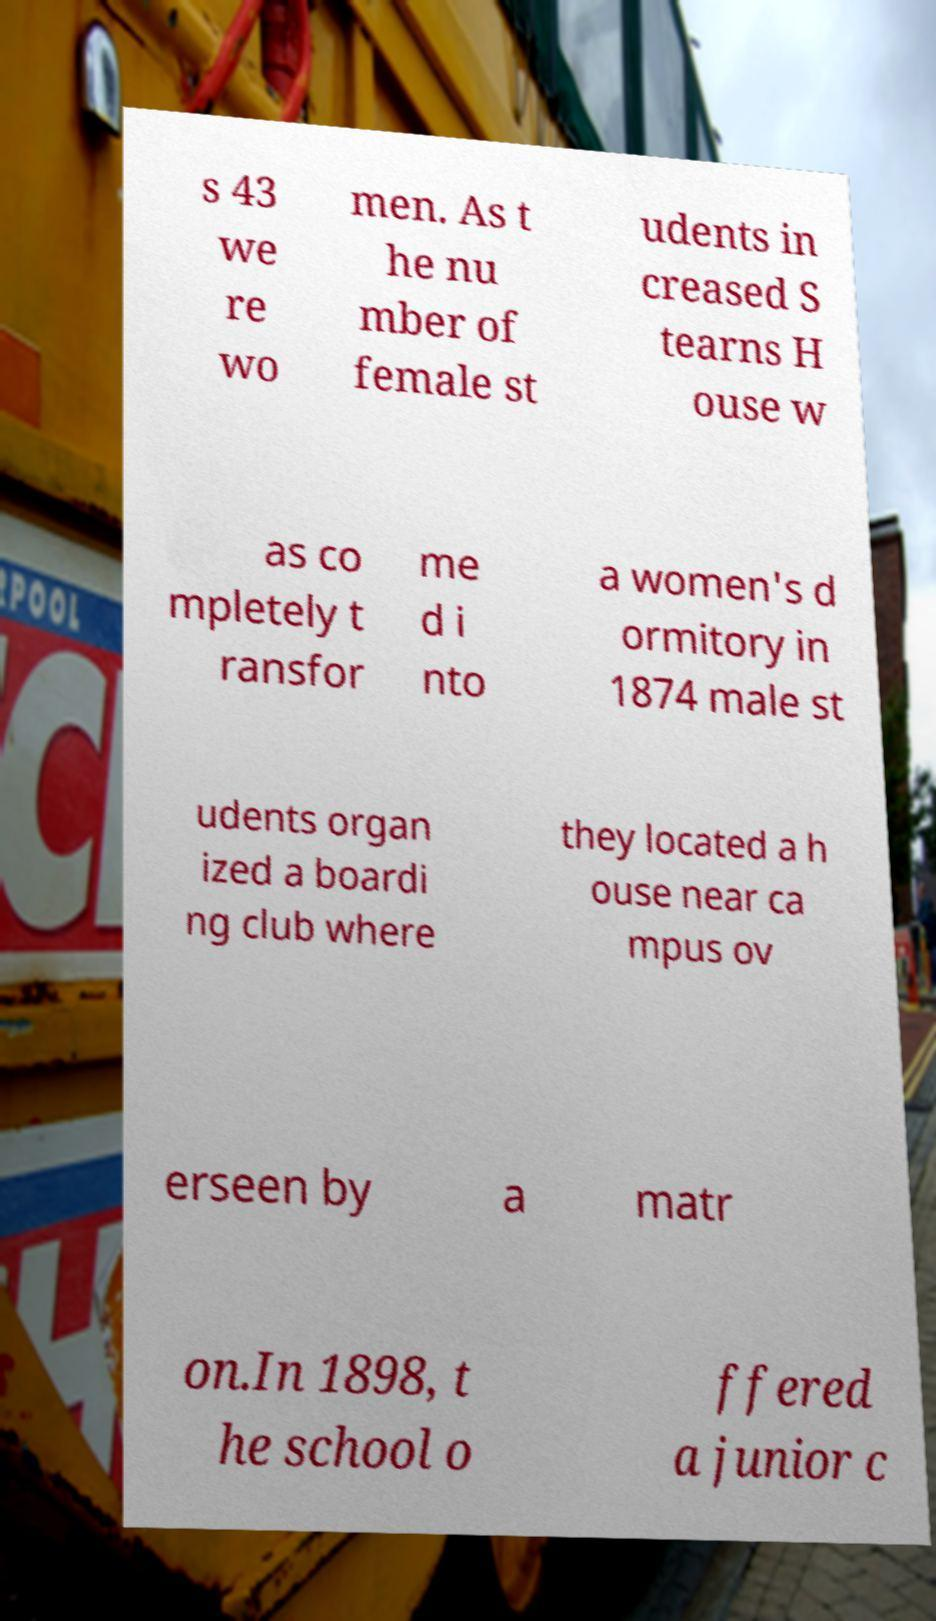What messages or text are displayed in this image? I need them in a readable, typed format. s 43 we re wo men. As t he nu mber of female st udents in creased S tearns H ouse w as co mpletely t ransfor me d i nto a women's d ormitory in 1874 male st udents organ ized a boardi ng club where they located a h ouse near ca mpus ov erseen by a matr on.In 1898, t he school o ffered a junior c 